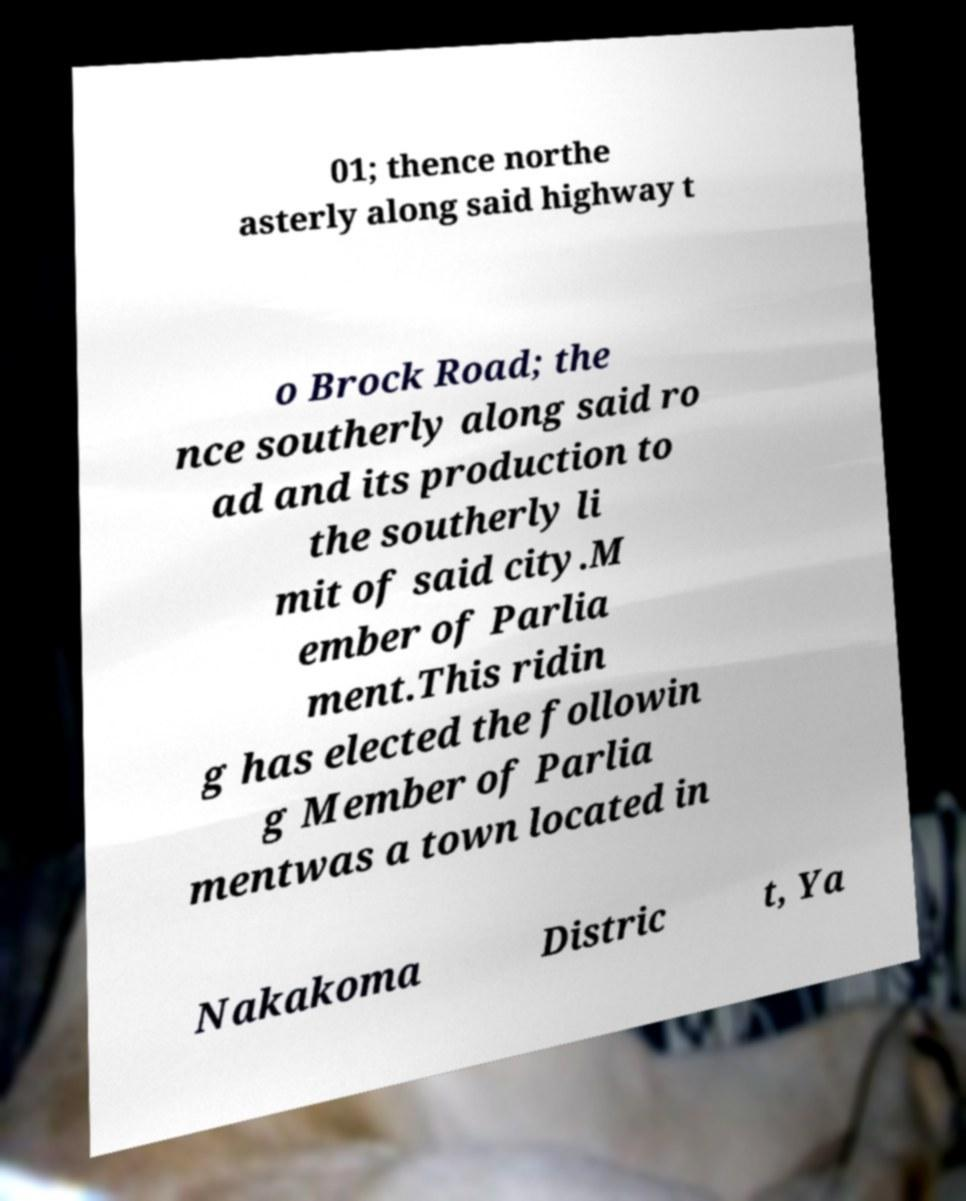Can you accurately transcribe the text from the provided image for me? 01; thence northe asterly along said highway t o Brock Road; the nce southerly along said ro ad and its production to the southerly li mit of said city.M ember of Parlia ment.This ridin g has elected the followin g Member of Parlia mentwas a town located in Nakakoma Distric t, Ya 